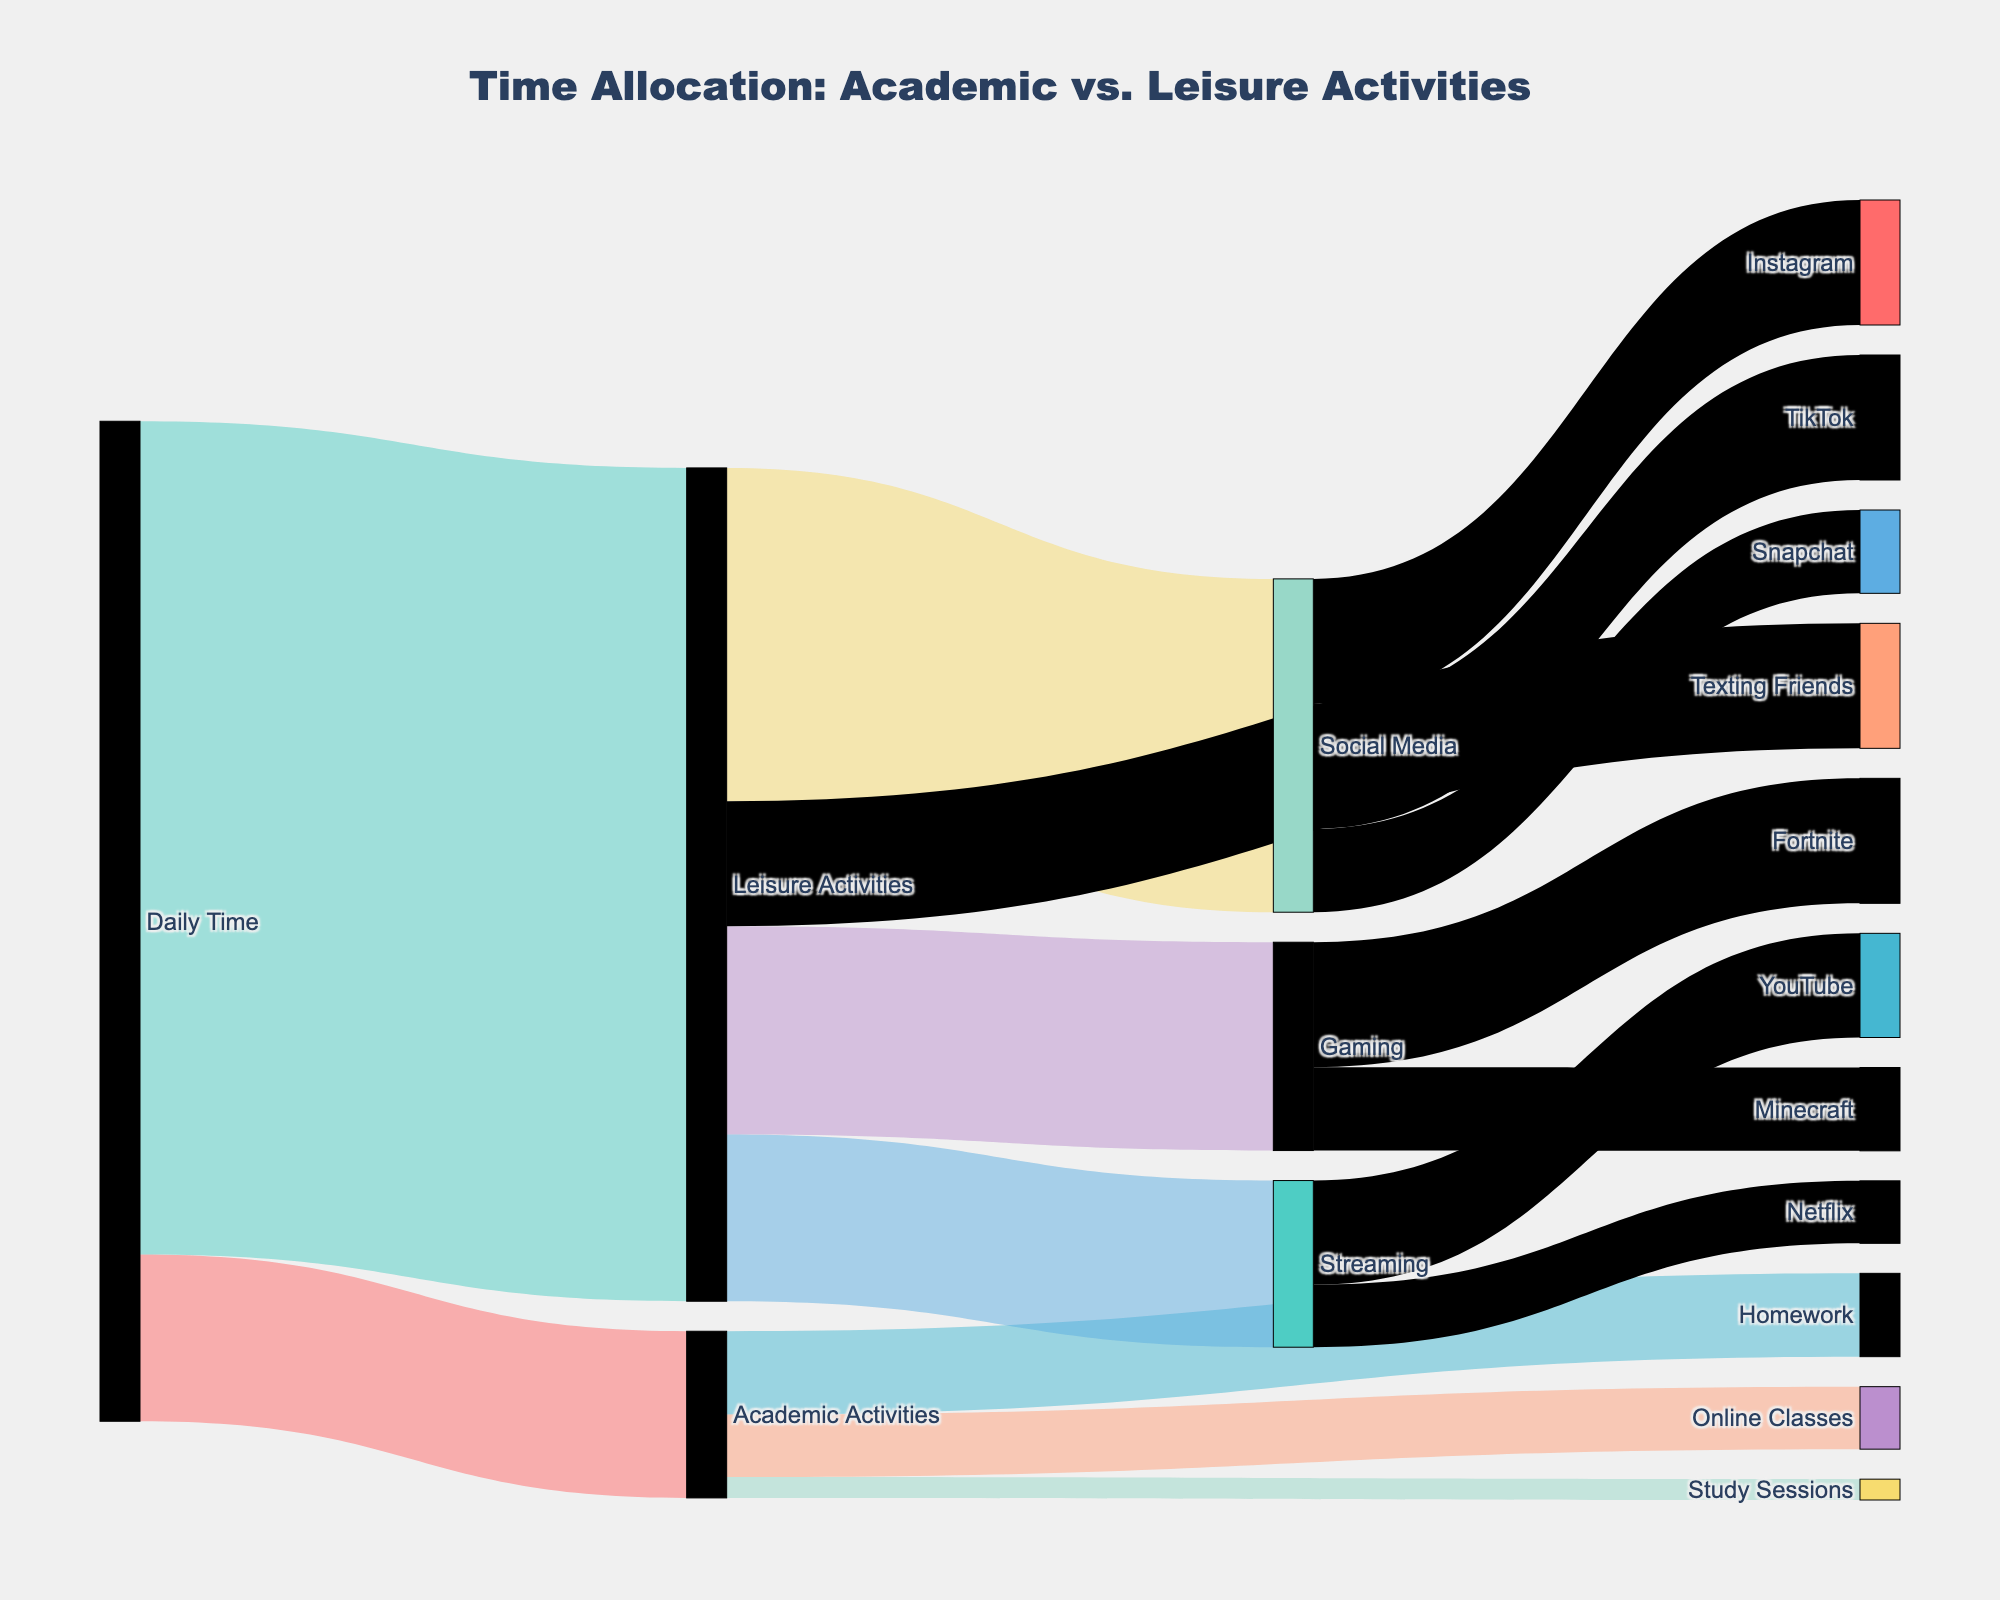What's the title of the figure? The title is usually at the top of the figure and describes what the figure is about. In this case, the title is "Time Allocation: Academic vs. Leisure Activities".
Answer: Time Allocation: Academic vs. Leisure Activities How much time is allocated to leisure activities daily? Look at the segment that links "Daily Time" to "Leisure Activities" and note the value. It shows "20" hours.
Answer: 20 hours Compare the time spent on Instagram and Snapchat. Which activity consumes more time? Check the segments linked to different social media activities under "Social Media". The segment for "Instagram" shows 3 hours and for "Snapchat" shows 2 hours.
Answer: Instagram What is the total time allocated to academic activities? Add up the values for segments linked from "Academic Activities" to "Homework", "Online Classes", and "Study Sessions". That's 2 + 1.5 + 0.5 hours.
Answer: 4 hours How much time is spent on gaming activities? Find the segment linked from "Leisure Activities" to "Gaming". The value shown in the link is 5 hours.
Answer: 5 hours What proportion of social media time is spent on TikTok? First, find the total time spent on social media (Instagram + TikTok + Snapchat, i.e., 3 + 3 + 2 = 8 hours). TikTok time is 3 hours. Proportion is 3/8.
Answer: 3/8 Between "Academic Activities" and "Leisure Activities", which takes up more daily time? Compare the links directly connected to "Daily Time". Academic Activities is 4 hours and Leisure Activities is 20 hours.
Answer: Leisure Activities Which streaming platform consumes the most time? Compare the segments connected to "Streaming". YouTube (2.5 hours) and Netflix (1.5 hours) show their respective values.
Answer: YouTube By how much does the time spent on Fortnite exceed the time spent on Minecraft? Check the segments under "Gaming". Fortnite is 3 hours, while Minecraft is 2 hours; the difference is 3 - 2.
Answer: 1 hour What is the combined daily time spent on YouTube and Netflix? Add the values for segments connected to "Streaming". YouTube (2.5 hours) plus Netflix (1.5 hours). That's 2.5 + 1.5.
Answer: 4 hours 